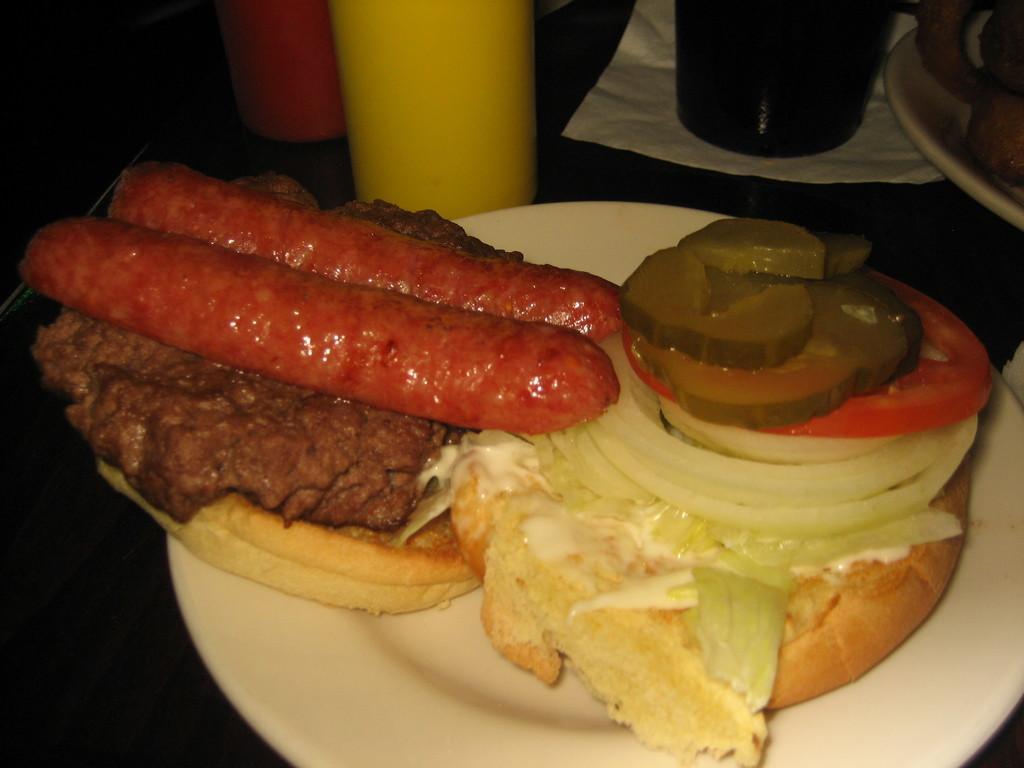In one or two sentences, can you explain what this image depicts? In this image there are plates and bottles on a surface. In the foreground there is a plate. There is food on the plate. There are hot dogs, tomatoes, zucchini, lettuce, meat and buns in the food. At the top there is a tissue below the bottle. 